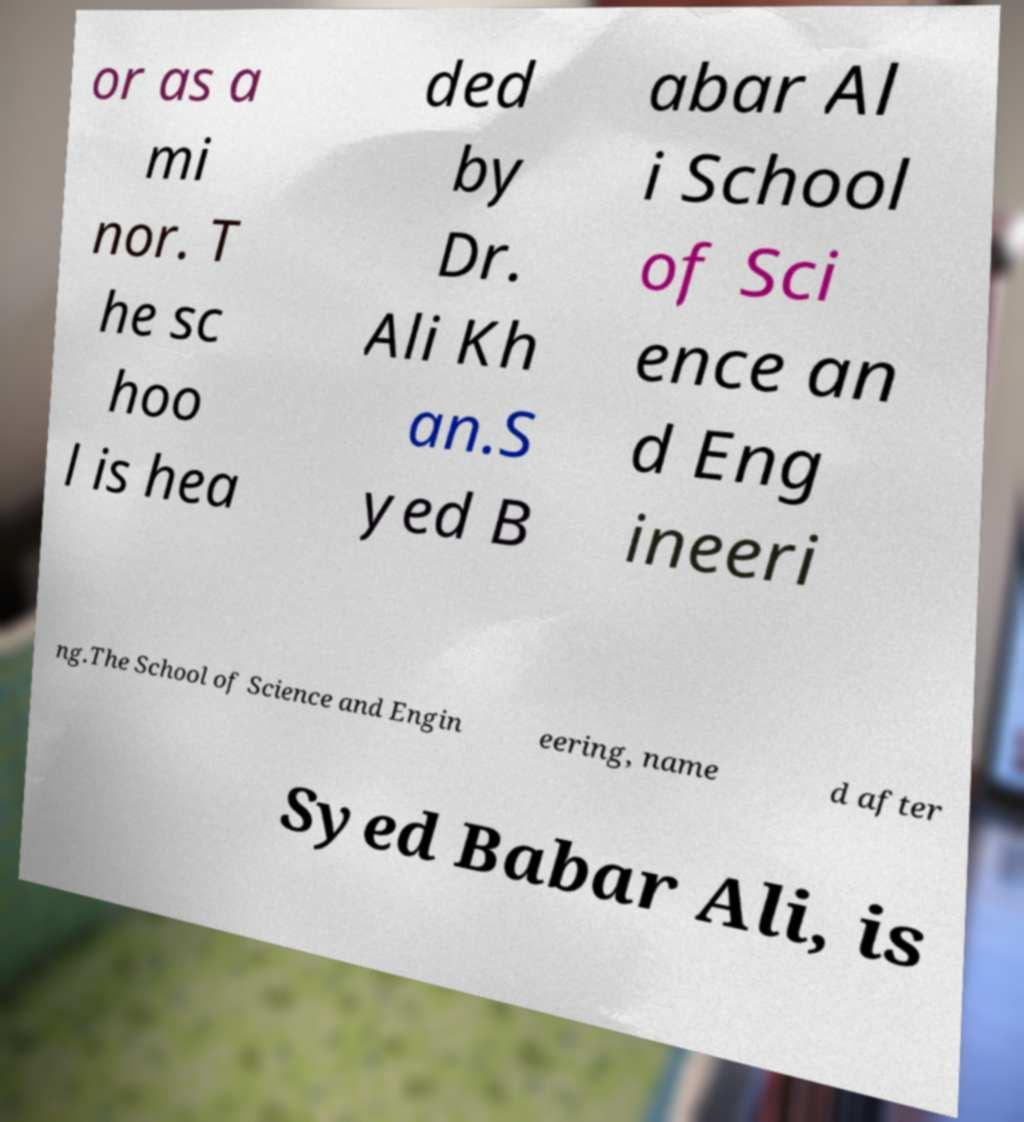Can you accurately transcribe the text from the provided image for me? or as a mi nor. T he sc hoo l is hea ded by Dr. Ali Kh an.S yed B abar Al i School of Sci ence an d Eng ineeri ng.The School of Science and Engin eering, name d after Syed Babar Ali, is 